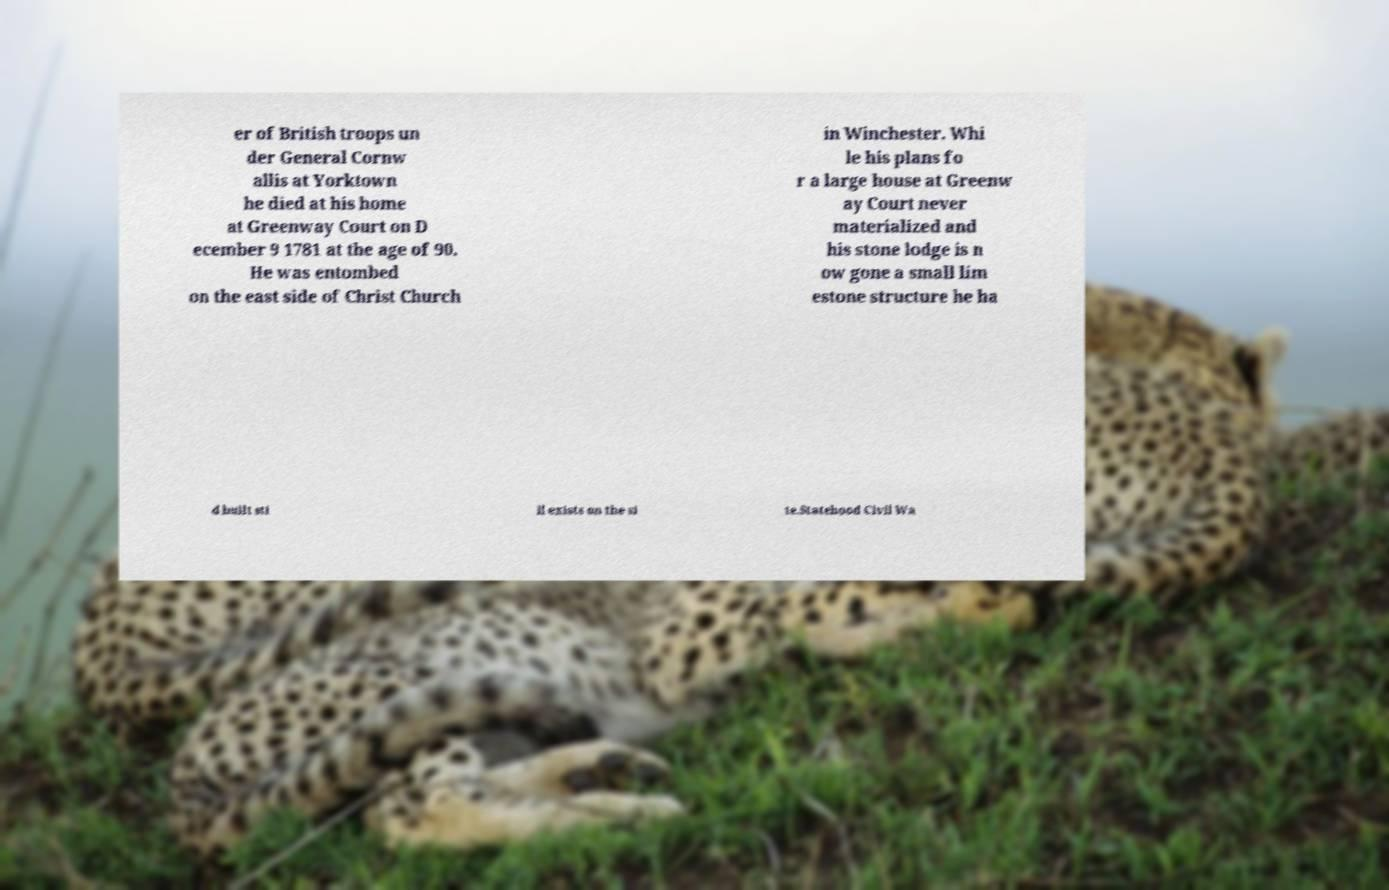Could you assist in decoding the text presented in this image and type it out clearly? er of British troops un der General Cornw allis at Yorktown he died at his home at Greenway Court on D ecember 9 1781 at the age of 90. He was entombed on the east side of Christ Church in Winchester. Whi le his plans fo r a large house at Greenw ay Court never materialized and his stone lodge is n ow gone a small lim estone structure he ha d built sti ll exists on the si te.Statehood Civil Wa 